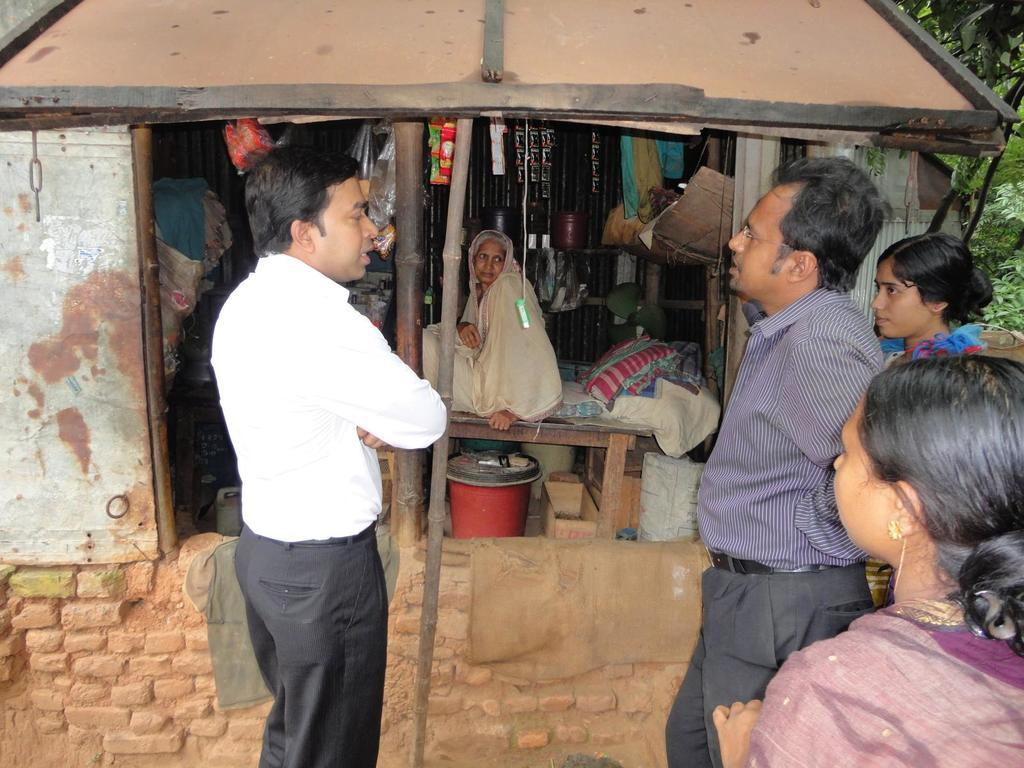What can be seen in the foreground of the image? There are people standing in the foreground of the image. What type of natural elements are visible in the image? There are trees visible in the image. What is the lady in the image doing? The lady is sitting on a bed in the image. What type of location does the image appear to depict? The setting appears to be a store. What can be seen in the background of the image? There are trees and a roof visible in the background of the image. Can you hear the thunder in the image? There is no mention of thunder or any sound in the image, so it cannot determine if it can be heard. What type of net is being used by the people in the image? There is no net visible in the image. What is the condition of the lady's knee in the image? There is no information about the lady's knee in the image. 